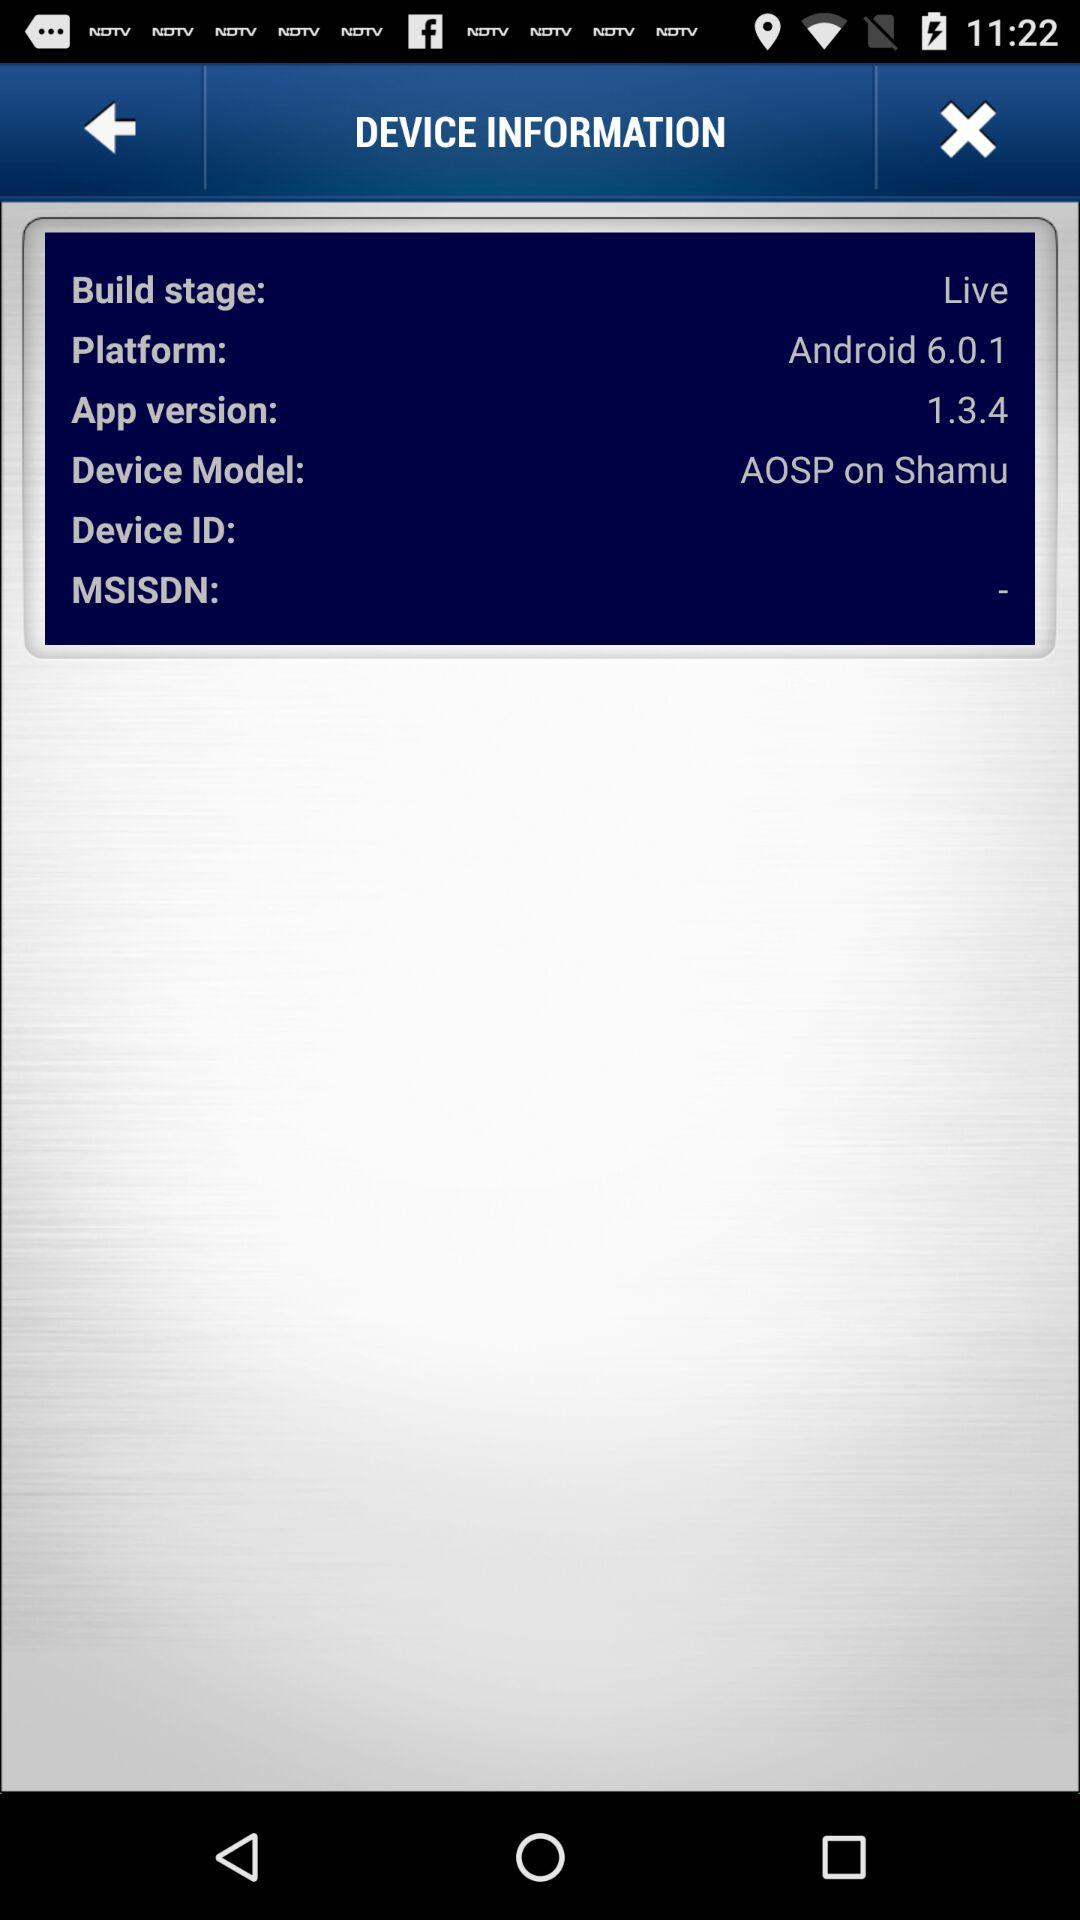What is the app version? The app version is 1.3.4. 